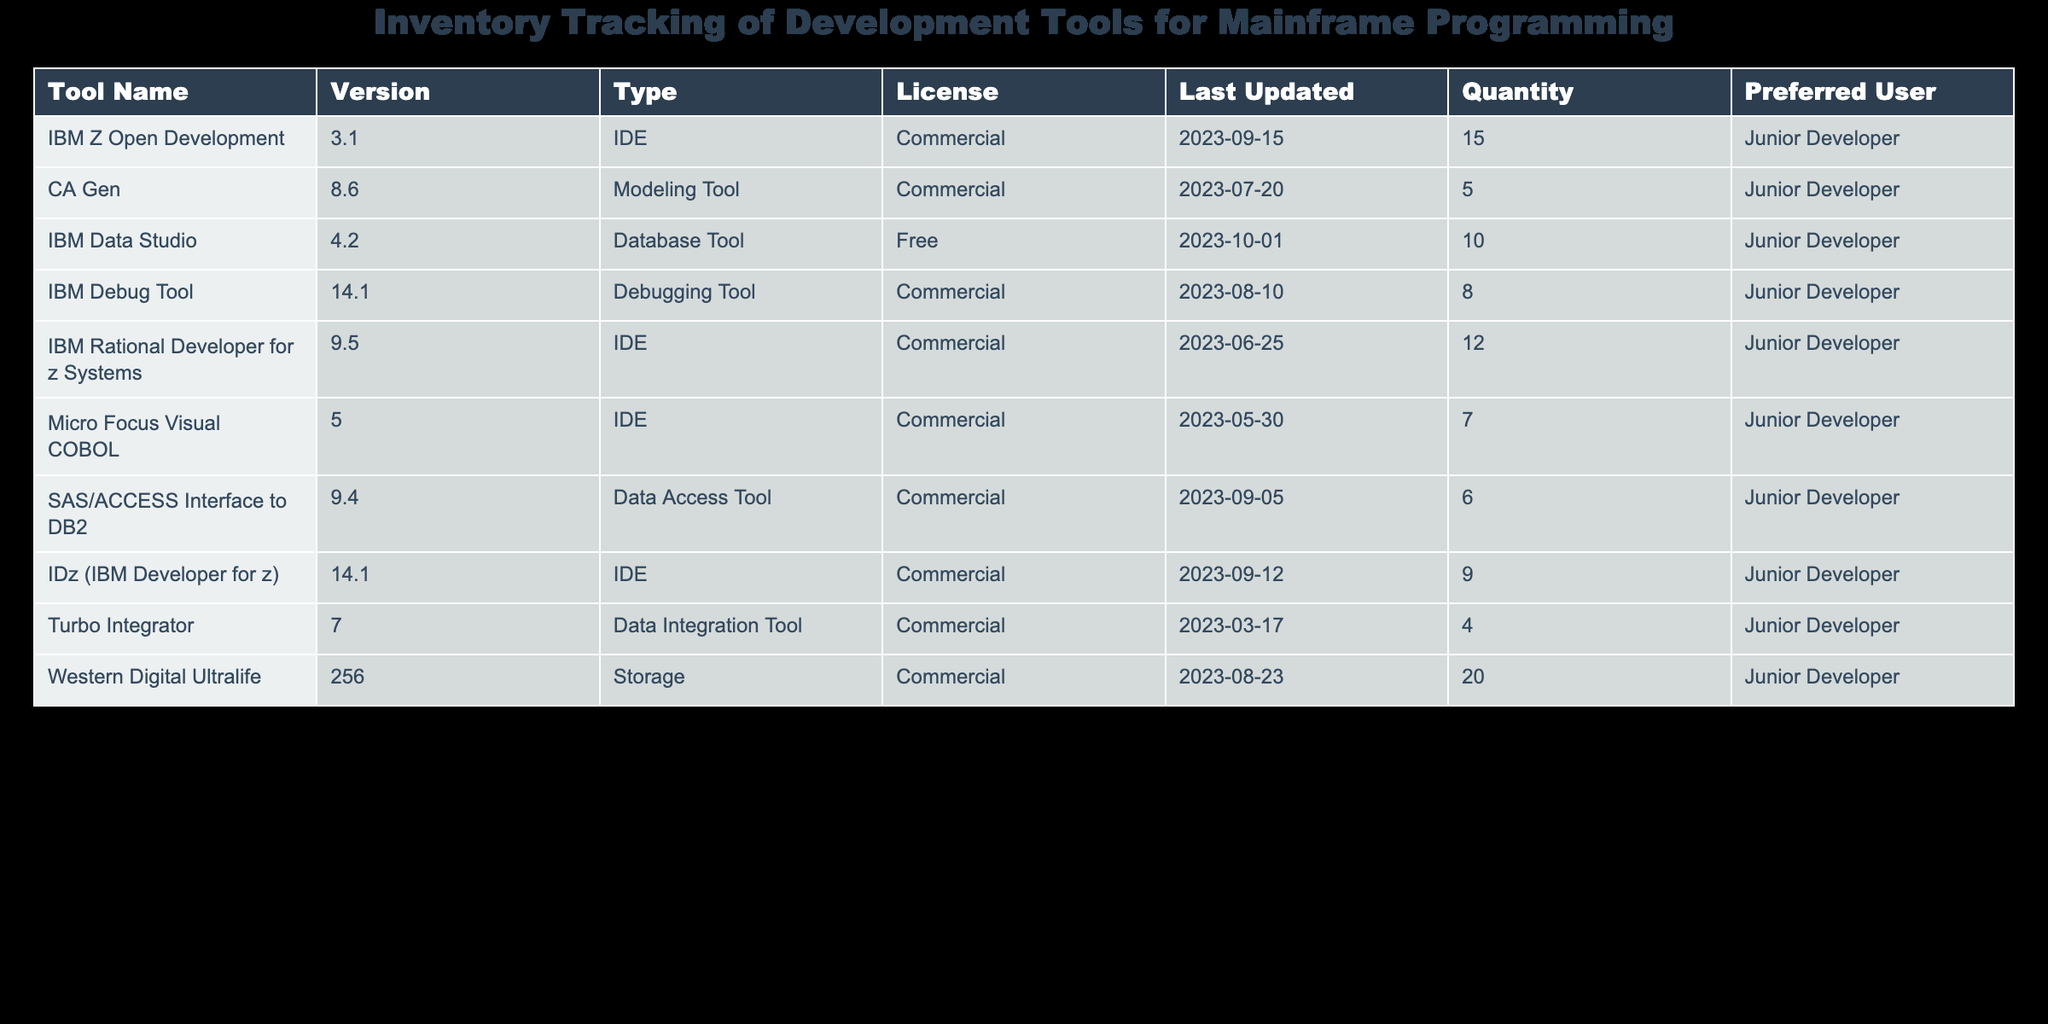What is the version of IBM Data Studio? The table lists the version of IBM Data Studio in the 'Version' column corresponding to the 'Tool Name' row for IBM Data Studio. It shows that the version is 4.2.
Answer: 4.2 How many total IDEs are listed in the inventory? To find the total number of IDEs, we look at the 'Type' column and count the number of times "IDE" appears. The tools are IBM Z Open Development, IBM Rational Developer for z Systems, Micro Focus Visual COBOL, IDz (IBM Developer for z), making it a total of 4 IDEs.
Answer: 4 Is there a tool available for data integration? Checking the 'Type' column for 'Data Integration Tool', we find that Turbo Integrator is listed under that category. Therefore, the answer to this question is yes.
Answer: Yes What is the total quantity of all the development tools in the inventory? To find the total quantity, we sum all the values in the 'Quantity' column: 15 (IBM Z Open Development) + 5 (CA Gen) + 10 (IBM Data Studio) + 8 (IBM Debug Tool) + 12 (IBM Rational Developer for z Systems) + 7 (Micro Focus Visual COBOL) + 6 (SAS/ACCESS Interface to DB2) + 9 (IDz) + 4 (Turbo Integrator) + 20 (Western Digital Ultralife) = 96.
Answer: 96 Which tool has the highest quantity and what is its quantity? Looking at the 'Quantity' column, the highest value is 20, which corresponds to Western Digital Ultralife in the 'Tool Name' column. Therefore, the answer is Western Digital Ultralife with a quantity of 20.
Answer: Western Digital Ultralife, 20 What is the most recent last updated date for a development tool? We check the 'Last Updated' column for the most recent date. The latest date is 2023-10-01 for IBM Data Studio.
Answer: 2023-10-01 What is the average quantity of tools preferred by Junior Developers? To find the average quantity, we sum the 'Quantity' values for tools preferred by Junior Developers (15 + 5 + 10 + 8 + 12 + 7 + 6 + 9 + 4 + 20 = 96) and divide by the number of tools (10). Thus, 96 / 10 = 9.6.
Answer: 9.6 Are there more commercial tools than free tools in the inventory? We count the tools categorized as commercial (9 total) and the number of free tools (1 total, which is IBM Data Studio). Since 9 is greater than 1, there are indeed more commercial tools than free ones.
Answer: Yes 